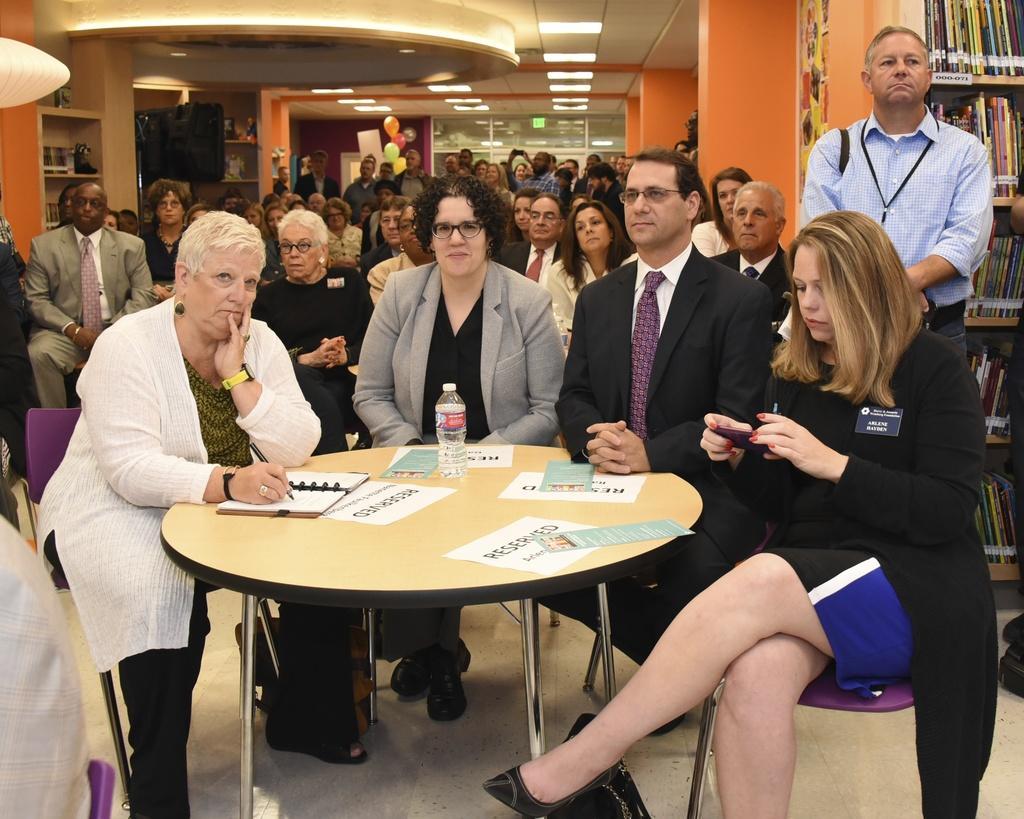How would you summarize this image in a sentence or two? In this image we can see there are a few people sitting on the chair. And at the side, we can see the person standing and there are racks at the back, in that there are different types of books. In front of the persons there is the table, on the table there are papers, cards, book and bottle. And there are two people holding cell phone and pen. At the back we can see the balloons, window and the black color object. 